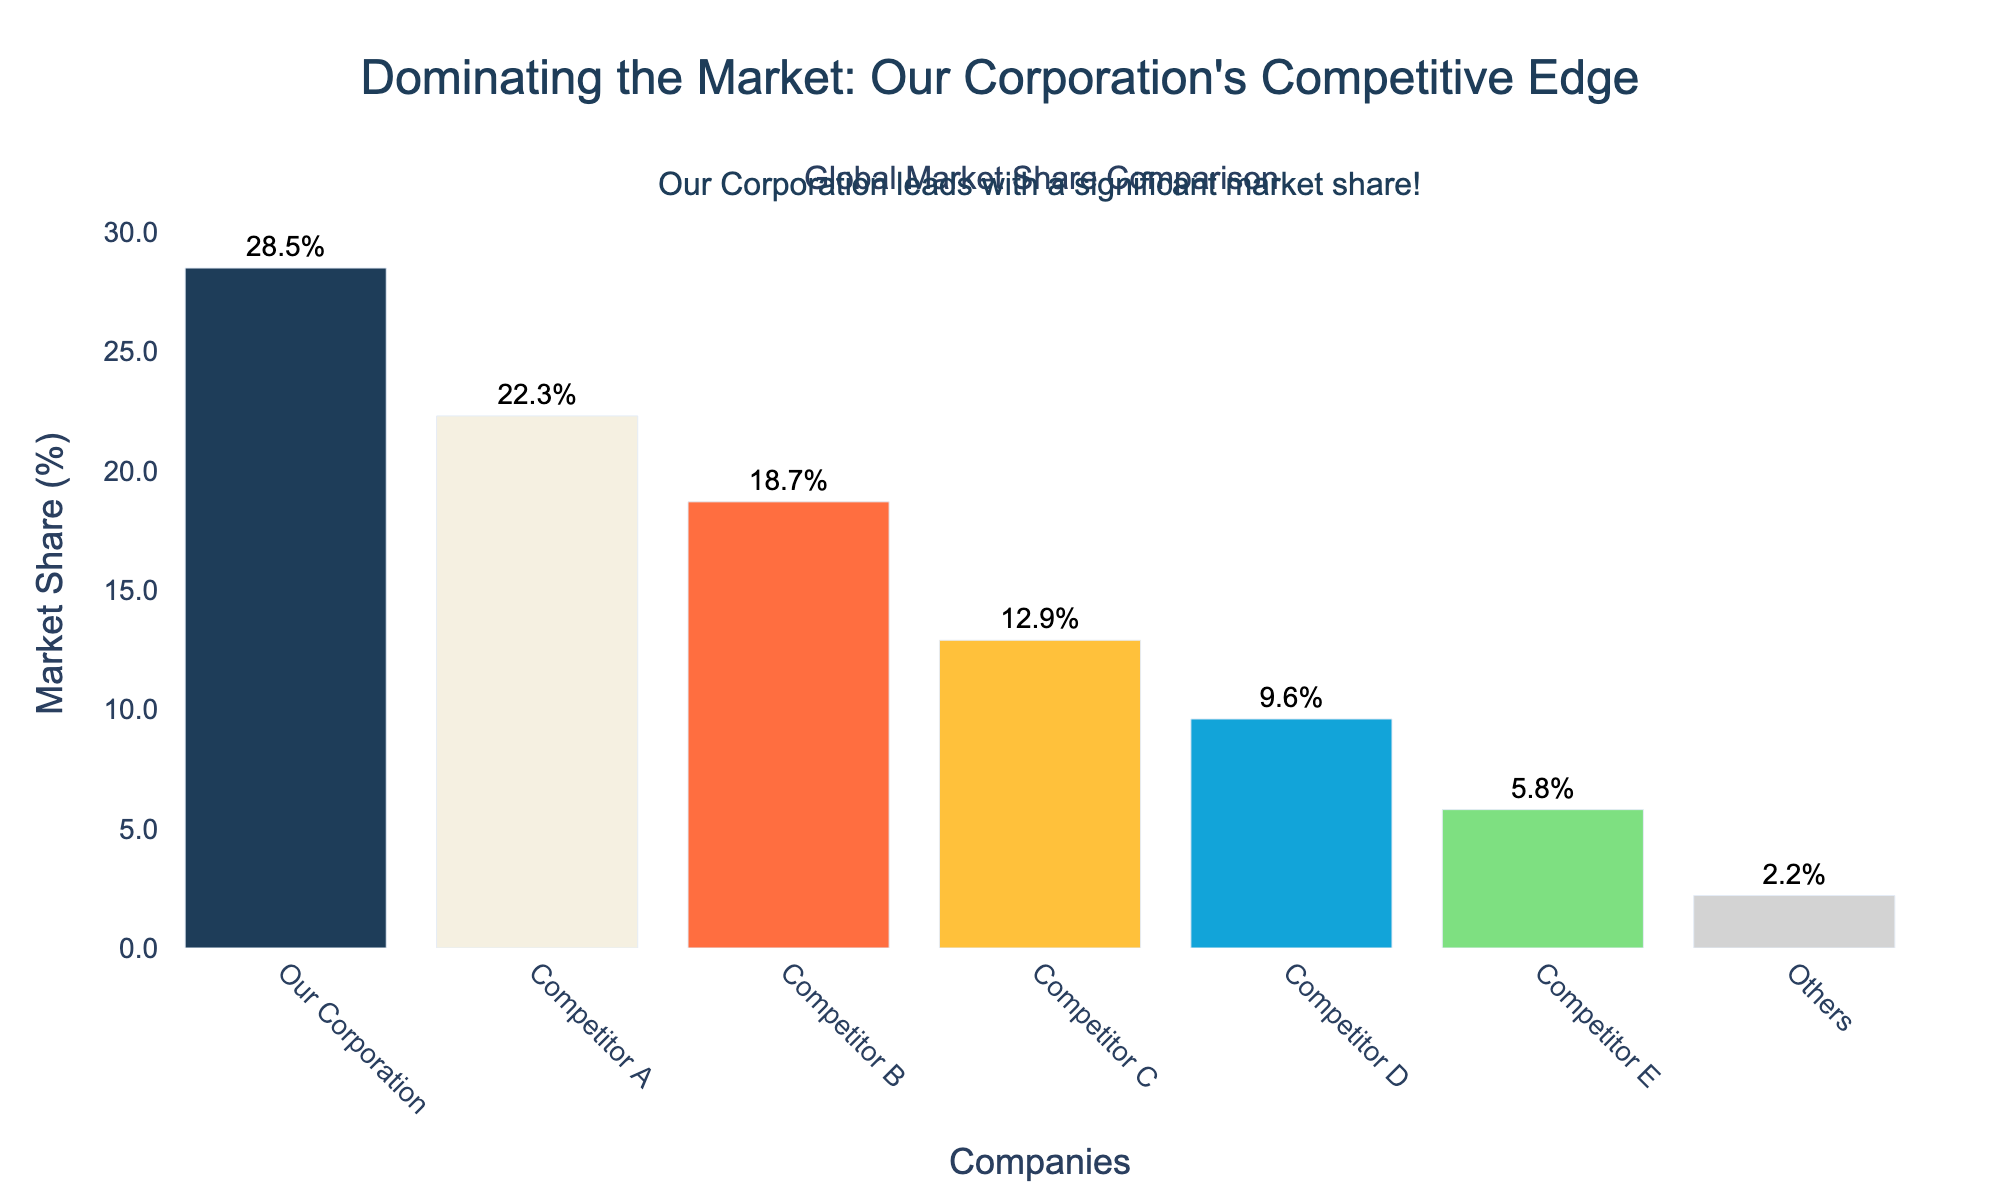What is the market share difference between Our Corporation and Competitor A? Our Corporation has a market share of 28.5%, and Competitor A has a market share of 22.3%. The difference is calculated by subtracting Competitor A's share from Our Corporation's share: 28.5% - 22.3% = 6.2%
Answer: 6.2% Among the top three companies, what is the total market share? The top three companies are Our Corporation (28.5%), Competitor A (22.3%), and Competitor B (18.7%). Their total market share is calculated by summing these percentages: 28.5% + 22.3% + 18.7% = 69.5%
Answer: 69.5% Which company has the smallest market share and what is it? The company with the smallest market share is Others, with a market share of 2.2%. This can be seen as the smallest bar in the chart.
Answer: Others with 2.2% How much greater is Our Corporation's market share than the combined shares of Competitor D and Competitor E? Our Corporation has a market share of 28.5%. Competitor D has 9.6%, and Competitor E has 5.8%. The combined share of Competitor D and E is 9.6% + 5.8% = 15.4%. The difference is 28.5% - 15.4% = 13.1%
Answer: 13.1% Which company or companies have a market share greater than 20%? Companies with market shares greater than 20% are Our Corporation (28.5%) and Competitor A (22.3%). These can be identified by their taller bars in the chart compared to the other companies.
Answer: Our Corporation and Competitor A What is the average market share of Competitor B, Competitor C, and Competitor D? The market shares are Competitor B (18.7%), Competitor C (12.9%), and Competitor D (9.6%). The average is calculated by summing these values and dividing by 3: (18.7% + 12.9% + 9.6%) / 3 = 13.733%.
Answer: 13.73% How does the market share of Competitor C compare to that of Competitor B? Competitor C has a market share of 12.9%, and Competitor B has 18.7%. Competitor C's share is less than Competitor B's by 18.7% - 12.9% = 5.8%.
Answer: Competitor C has 5.8% less What is the sum of the market shares of Competitors A, B, and E? The market shares are Competitor A (22.3%), Competitor B (18.7%), and Competitor E (5.8%). The sum of these shares is calculated as 22.3% + 18.7% + 5.8% = 46.8%.
Answer: 46.8% 